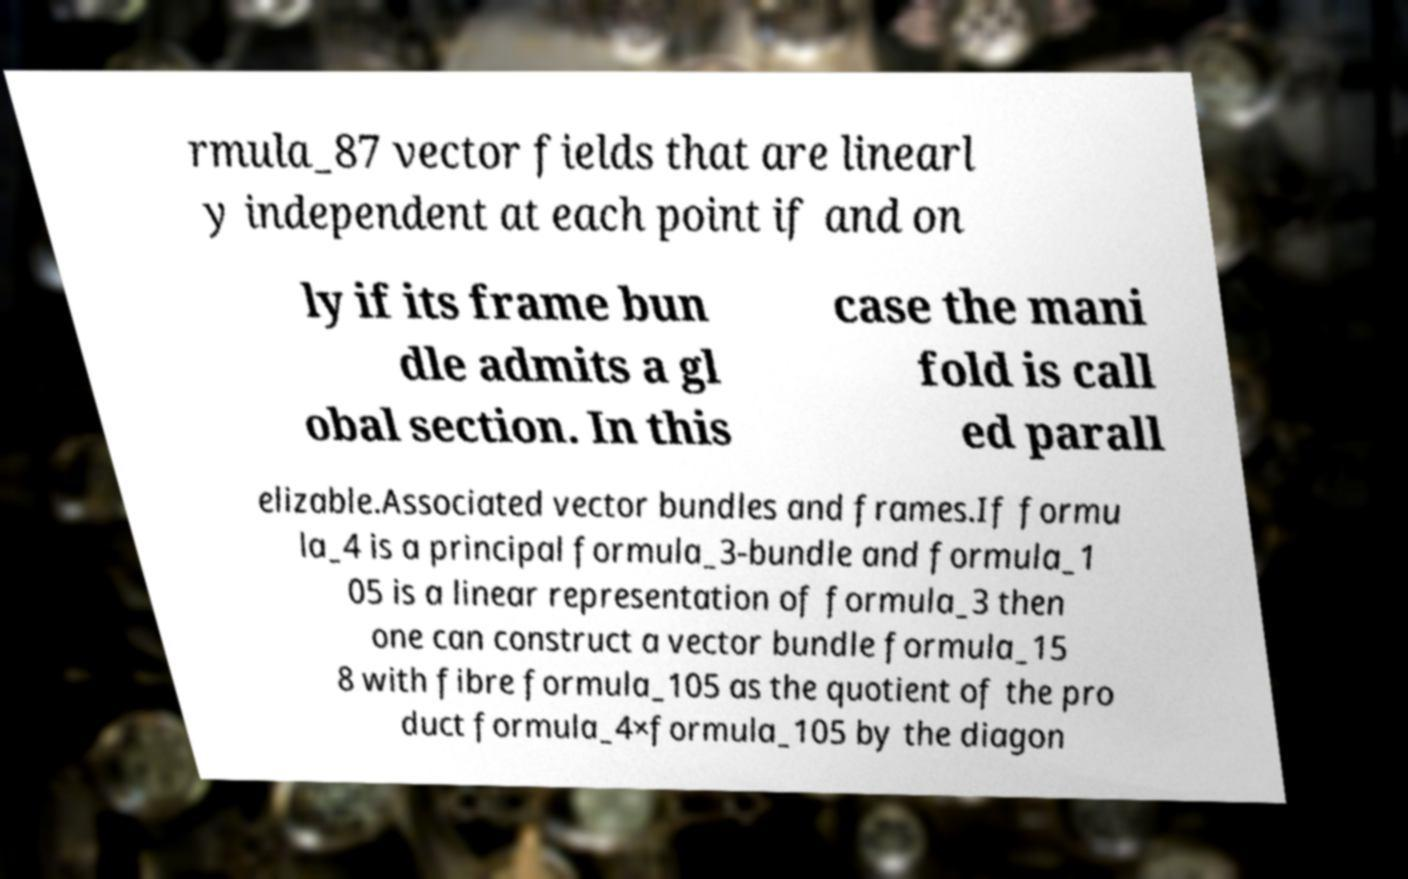Could you extract and type out the text from this image? rmula_87 vector fields that are linearl y independent at each point if and on ly if its frame bun dle admits a gl obal section. In this case the mani fold is call ed parall elizable.Associated vector bundles and frames.If formu la_4 is a principal formula_3-bundle and formula_1 05 is a linear representation of formula_3 then one can construct a vector bundle formula_15 8 with fibre formula_105 as the quotient of the pro duct formula_4×formula_105 by the diagon 